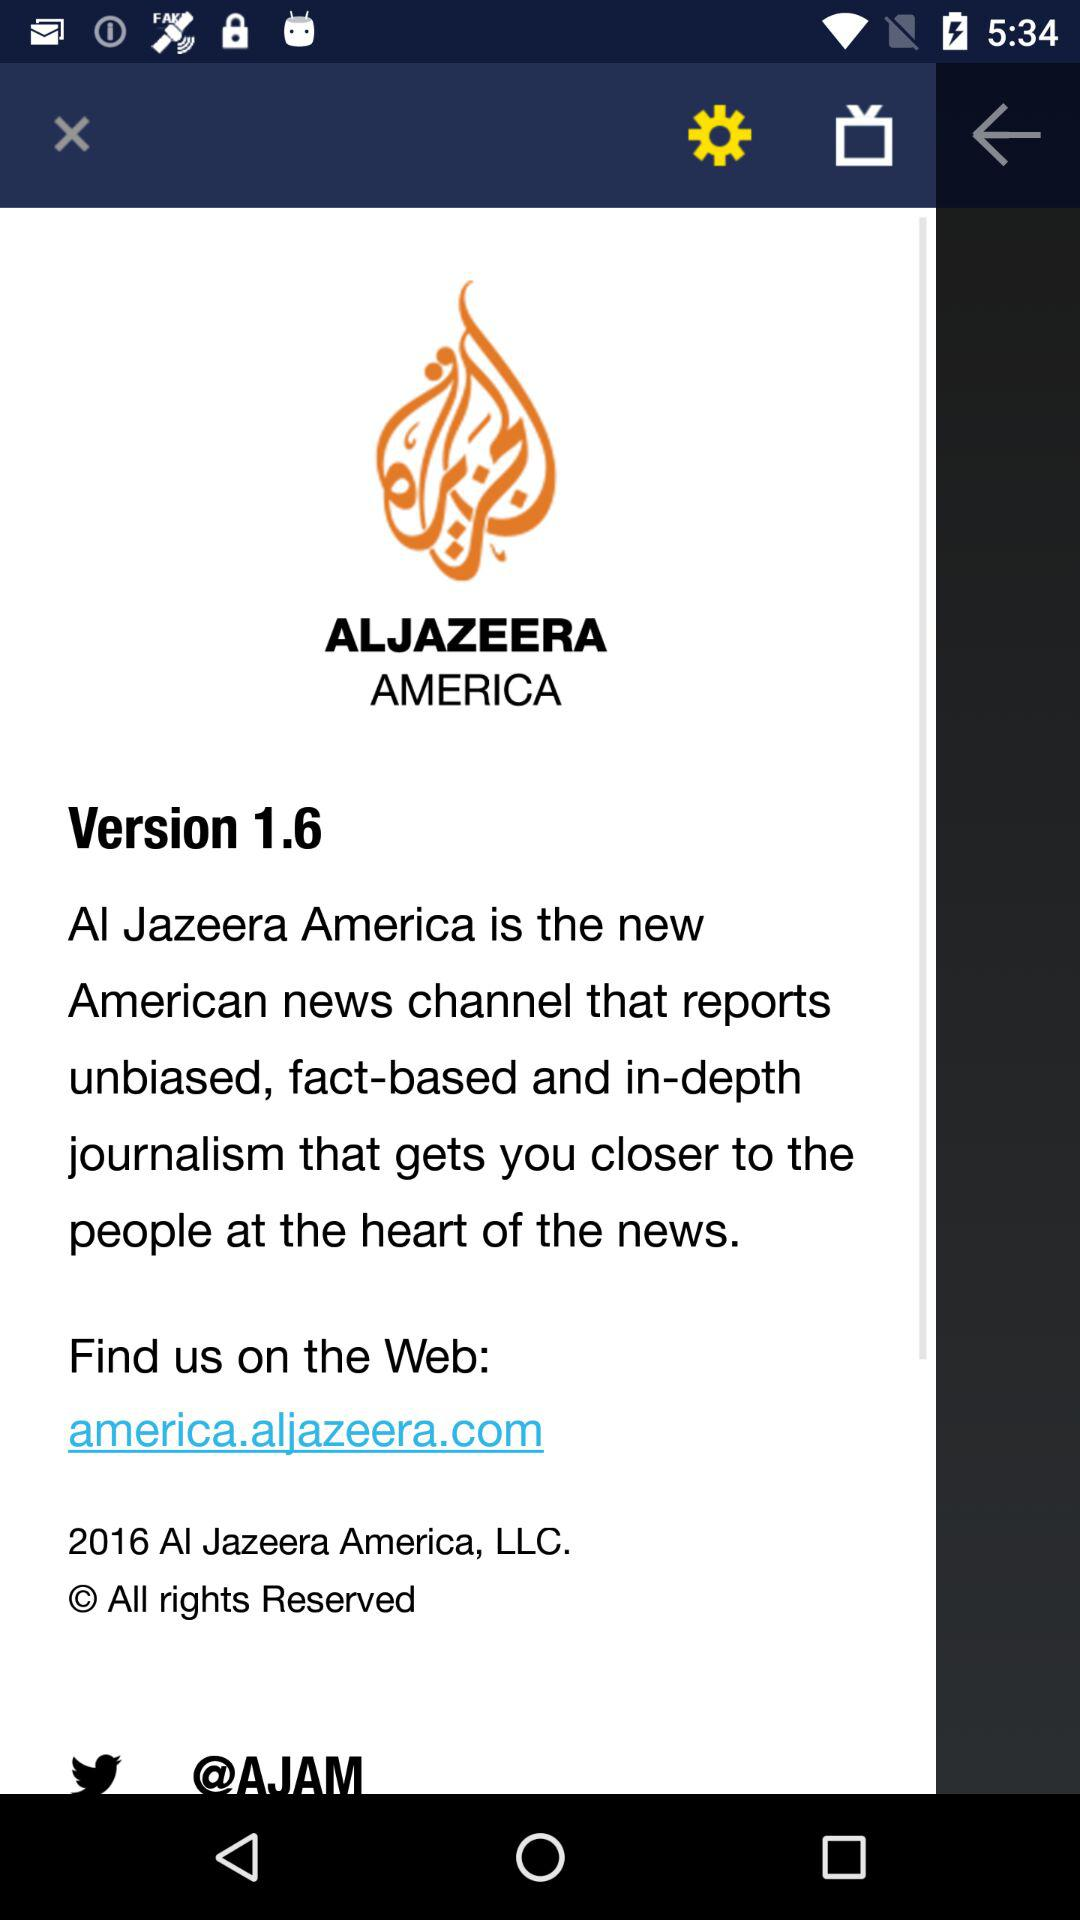What is the version of the application? The version of the application is 1.6. 